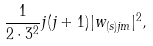Convert formula to latex. <formula><loc_0><loc_0><loc_500><loc_500>\frac { 1 } { 2 \cdot 3 ^ { 2 } } j ( j + 1 ) | w _ { ( s ) j m } | ^ { 2 } ,</formula> 